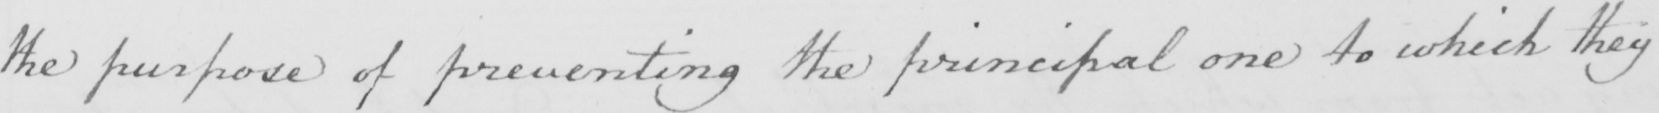Transcribe the text shown in this historical manuscript line. the purpose of preventing the principal one to which they 